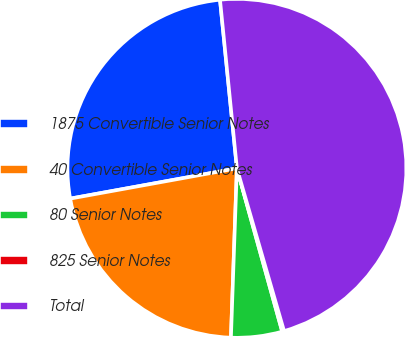Convert chart. <chart><loc_0><loc_0><loc_500><loc_500><pie_chart><fcel>1875 Convertible Senior Notes<fcel>40 Convertible Senior Notes<fcel>80 Senior Notes<fcel>825 Senior Notes<fcel>Total<nl><fcel>26.27%<fcel>21.58%<fcel>4.87%<fcel>0.18%<fcel>47.1%<nl></chart> 